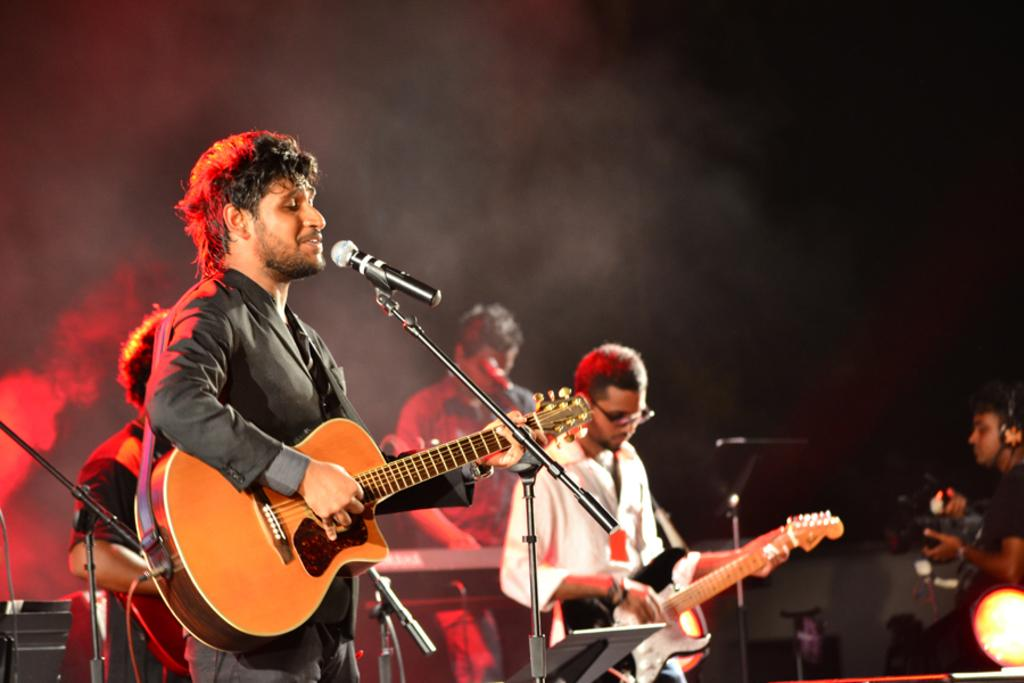What are the people in the image doing? The people in the image are playing musical instruments. What object is present that might be used for amplifying sound? There is a microphone in the image. What can be seen in the background of the image? Smoke is visible in the background of the image. What type of pet can be seen playing with a toy in the image? There is no pet or toy present in the image; it features people playing musical instruments and a microphone. 